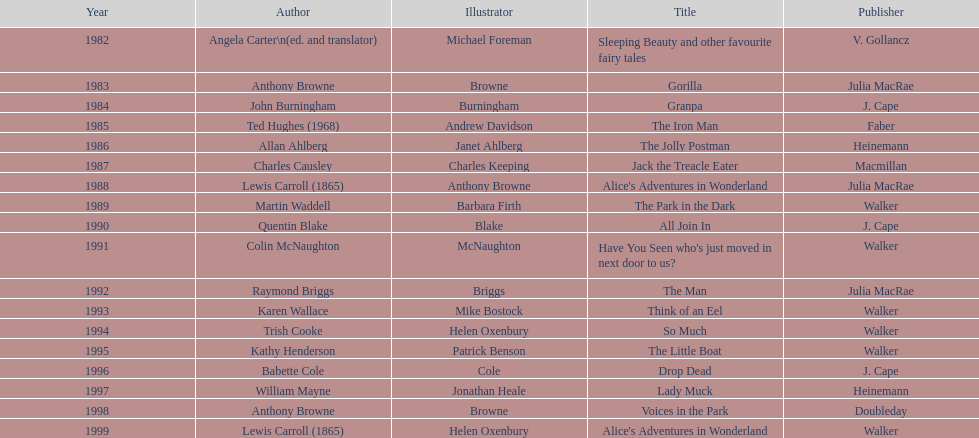How many publications does walker have under their name? 6. 